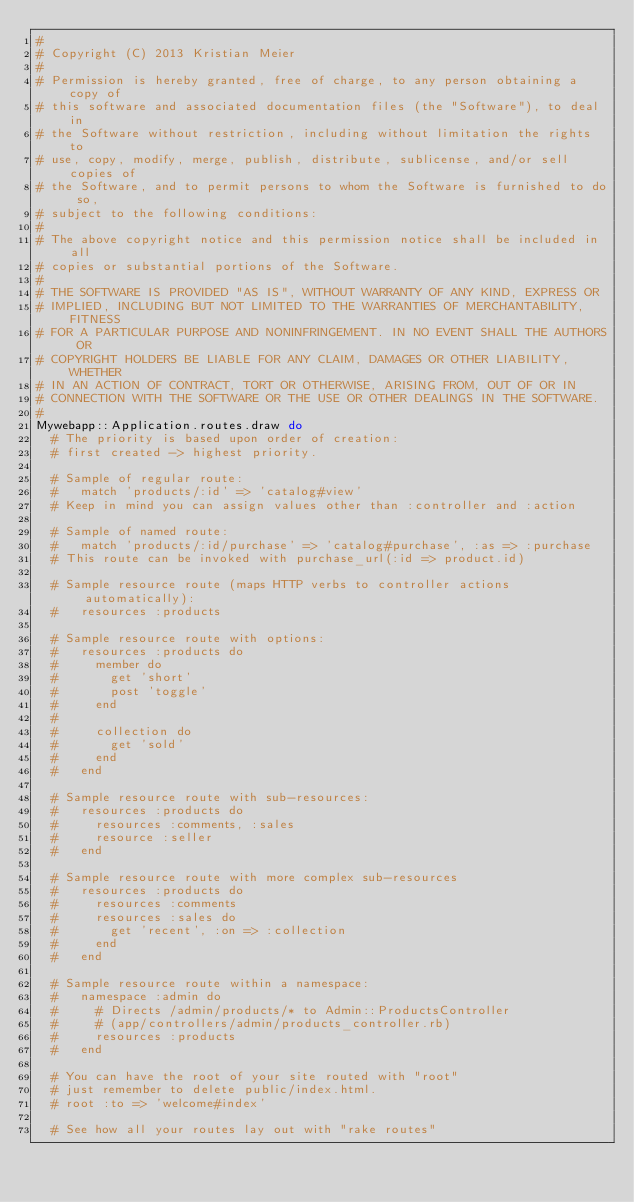<code> <loc_0><loc_0><loc_500><loc_500><_Ruby_>#
# Copyright (C) 2013 Kristian Meier
#
# Permission is hereby granted, free of charge, to any person obtaining a copy of
# this software and associated documentation files (the "Software"), to deal in
# the Software without restriction, including without limitation the rights to
# use, copy, modify, merge, publish, distribute, sublicense, and/or sell copies of
# the Software, and to permit persons to whom the Software is furnished to do so,
# subject to the following conditions:
#
# The above copyright notice and this permission notice shall be included in all
# copies or substantial portions of the Software.
#
# THE SOFTWARE IS PROVIDED "AS IS", WITHOUT WARRANTY OF ANY KIND, EXPRESS OR
# IMPLIED, INCLUDING BUT NOT LIMITED TO THE WARRANTIES OF MERCHANTABILITY, FITNESS
# FOR A PARTICULAR PURPOSE AND NONINFRINGEMENT. IN NO EVENT SHALL THE AUTHORS OR
# COPYRIGHT HOLDERS BE LIABLE FOR ANY CLAIM, DAMAGES OR OTHER LIABILITY, WHETHER
# IN AN ACTION OF CONTRACT, TORT OR OTHERWISE, ARISING FROM, OUT OF OR IN
# CONNECTION WITH THE SOFTWARE OR THE USE OR OTHER DEALINGS IN THE SOFTWARE.
#
Mywebapp::Application.routes.draw do
  # The priority is based upon order of creation:
  # first created -> highest priority.

  # Sample of regular route:
  #   match 'products/:id' => 'catalog#view'
  # Keep in mind you can assign values other than :controller and :action

  # Sample of named route:
  #   match 'products/:id/purchase' => 'catalog#purchase', :as => :purchase
  # This route can be invoked with purchase_url(:id => product.id)

  # Sample resource route (maps HTTP verbs to controller actions automatically):
  #   resources :products

  # Sample resource route with options:
  #   resources :products do
  #     member do
  #       get 'short'
  #       post 'toggle'
  #     end
  #
  #     collection do
  #       get 'sold'
  #     end
  #   end

  # Sample resource route with sub-resources:
  #   resources :products do
  #     resources :comments, :sales
  #     resource :seller
  #   end

  # Sample resource route with more complex sub-resources
  #   resources :products do
  #     resources :comments
  #     resources :sales do
  #       get 'recent', :on => :collection
  #     end
  #   end

  # Sample resource route within a namespace:
  #   namespace :admin do
  #     # Directs /admin/products/* to Admin::ProductsController
  #     # (app/controllers/admin/products_controller.rb)
  #     resources :products
  #   end

  # You can have the root of your site routed with "root"
  # just remember to delete public/index.html.
  # root :to => 'welcome#index'

  # See how all your routes lay out with "rake routes"
</code> 